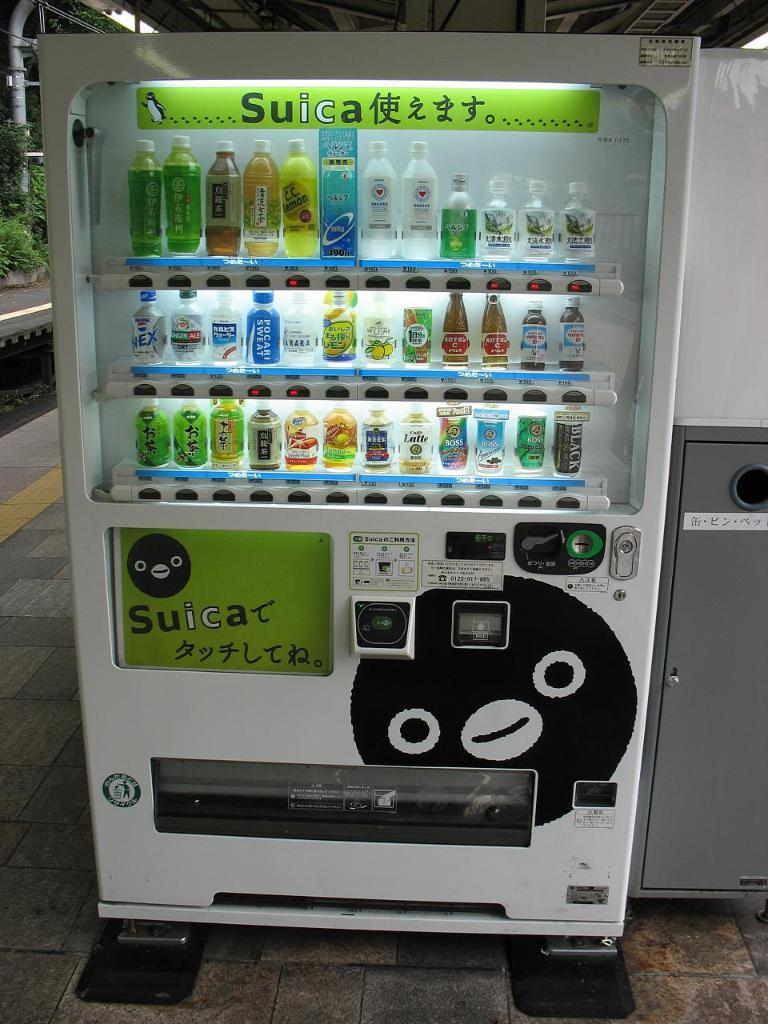What is located on the floor in the image? There is a machine on the floor in the image. What can be seen in the racks in the image? There are bottles in the racks in the image. What type of vegetation is visible in the background of the image? There are plants in the background of the image. What architectural feature is visible in the background of the image? There is a pipe in the background of the image. What is the highest point visible in the background of the image? There is a roof in the background of the image. Can you describe any other objects visible in the background of the image? There are some unspecified objects in the background of the image. Where is the market located in the image? There is no market present in the image. Can you describe the fight happening in the background of the image? There is no fight present in the image. 